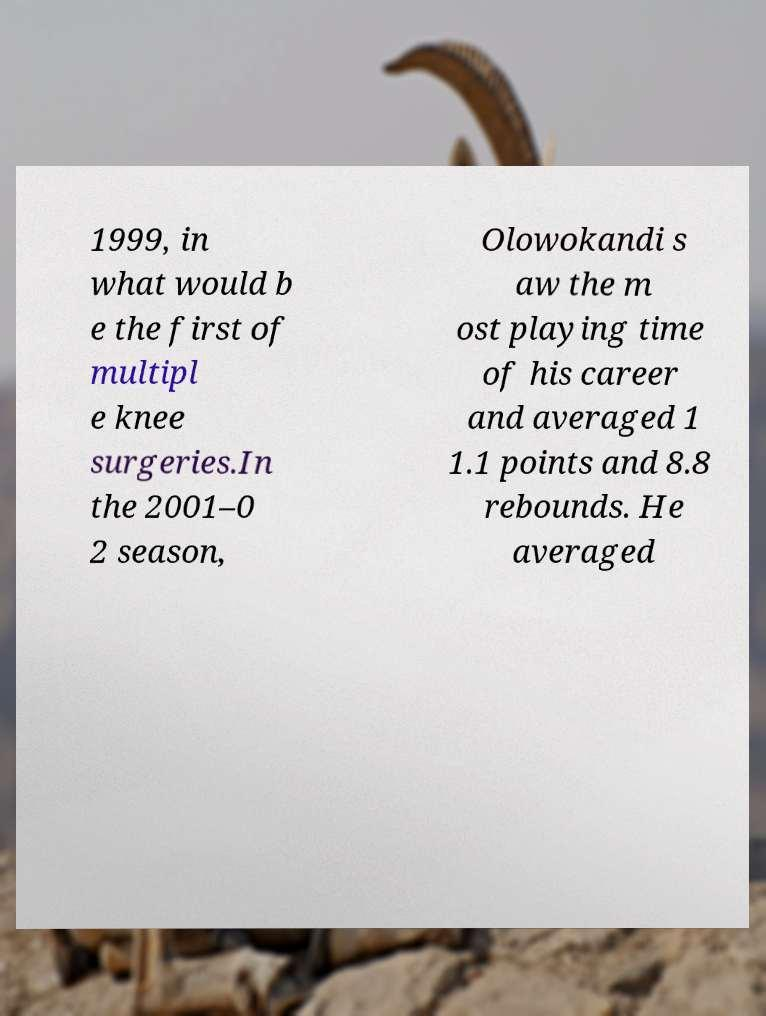Please identify and transcribe the text found in this image. 1999, in what would b e the first of multipl e knee surgeries.In the 2001–0 2 season, Olowokandi s aw the m ost playing time of his career and averaged 1 1.1 points and 8.8 rebounds. He averaged 